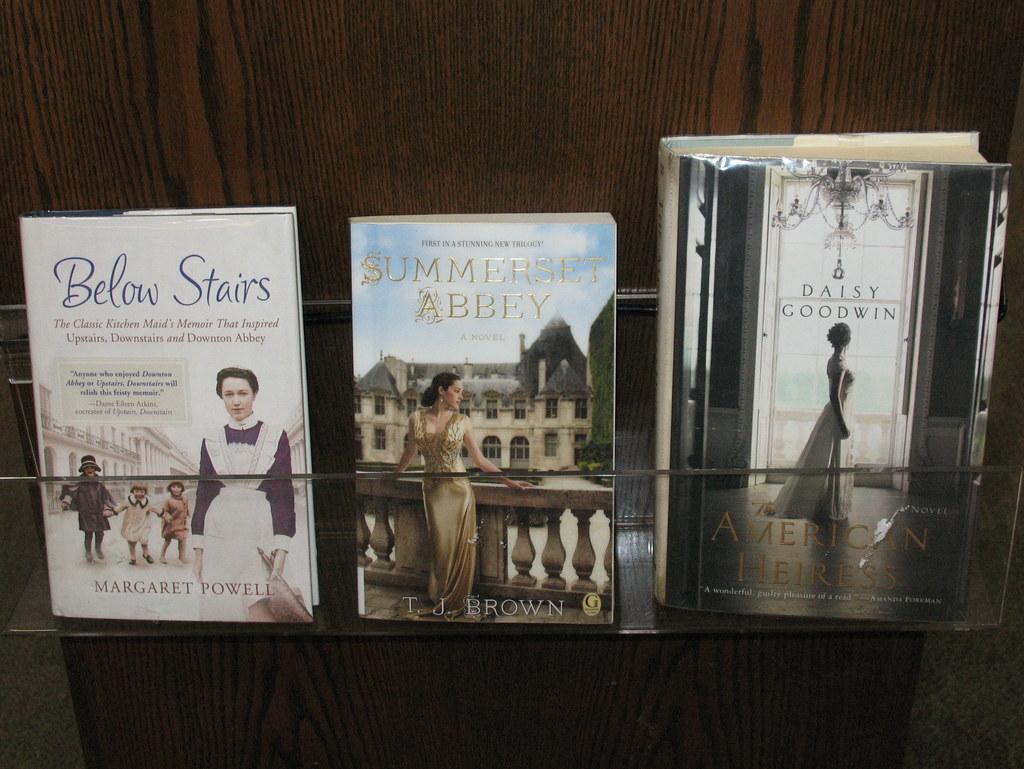In one or two sentences, can you explain what this image depicts? In this image we can see the books with the names and are placed on the wooden rack. We can also see the floor. 